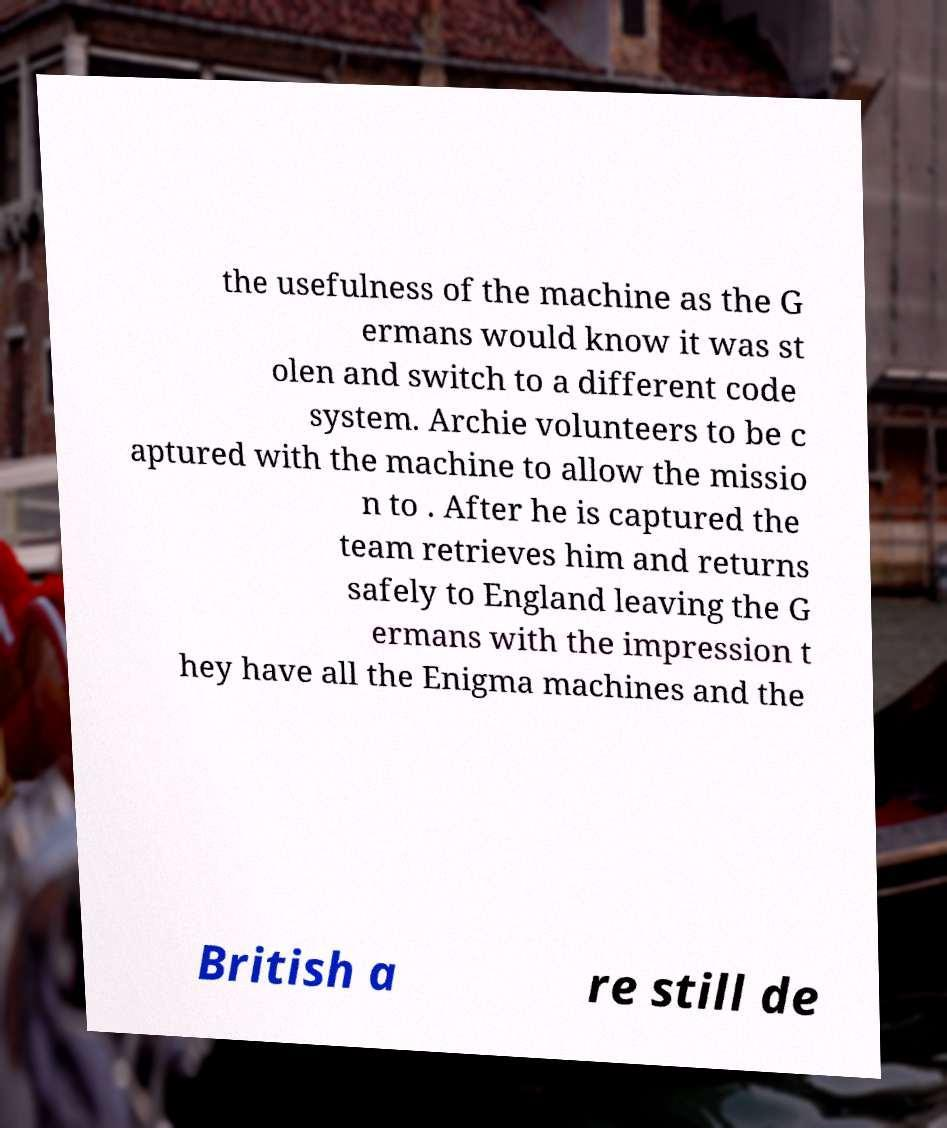Please identify and transcribe the text found in this image. the usefulness of the machine as the G ermans would know it was st olen and switch to a different code system. Archie volunteers to be c aptured with the machine to allow the missio n to . After he is captured the team retrieves him and returns safely to England leaving the G ermans with the impression t hey have all the Enigma machines and the British a re still de 